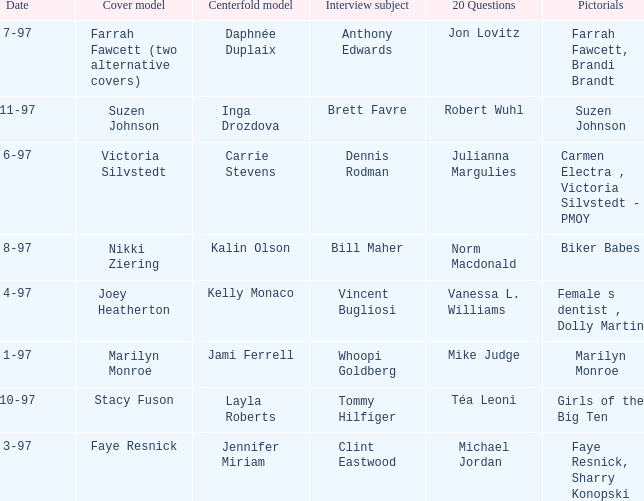Who was the centerfold model when a pictorial was done on marilyn monroe? Jami Ferrell. Could you parse the entire table? {'header': ['Date', 'Cover model', 'Centerfold model', 'Interview subject', '20 Questions', 'Pictorials'], 'rows': [['7-97', 'Farrah Fawcett (two alternative covers)', 'Daphnée Duplaix', 'Anthony Edwards', 'Jon Lovitz', 'Farrah Fawcett, Brandi Brandt'], ['11-97', 'Suzen Johnson', 'Inga Drozdova', 'Brett Favre', 'Robert Wuhl', 'Suzen Johnson'], ['6-97', 'Victoria Silvstedt', 'Carrie Stevens', 'Dennis Rodman', 'Julianna Margulies', 'Carmen Electra , Victoria Silvstedt - PMOY'], ['8-97', 'Nikki Ziering', 'Kalin Olson', 'Bill Maher', 'Norm Macdonald', 'Biker Babes'], ['4-97', 'Joey Heatherton', 'Kelly Monaco', 'Vincent Bugliosi', 'Vanessa L. Williams', 'Female s dentist , Dolly Martin'], ['1-97', 'Marilyn Monroe', 'Jami Ferrell', 'Whoopi Goldberg', 'Mike Judge', 'Marilyn Monroe'], ['10-97', 'Stacy Fuson', 'Layla Roberts', 'Tommy Hilfiger', 'Téa Leoni', 'Girls of the Big Ten'], ['3-97', 'Faye Resnick', 'Jennifer Miriam', 'Clint Eastwood', 'Michael Jordan', 'Faye Resnick, Sharry Konopski']]} 